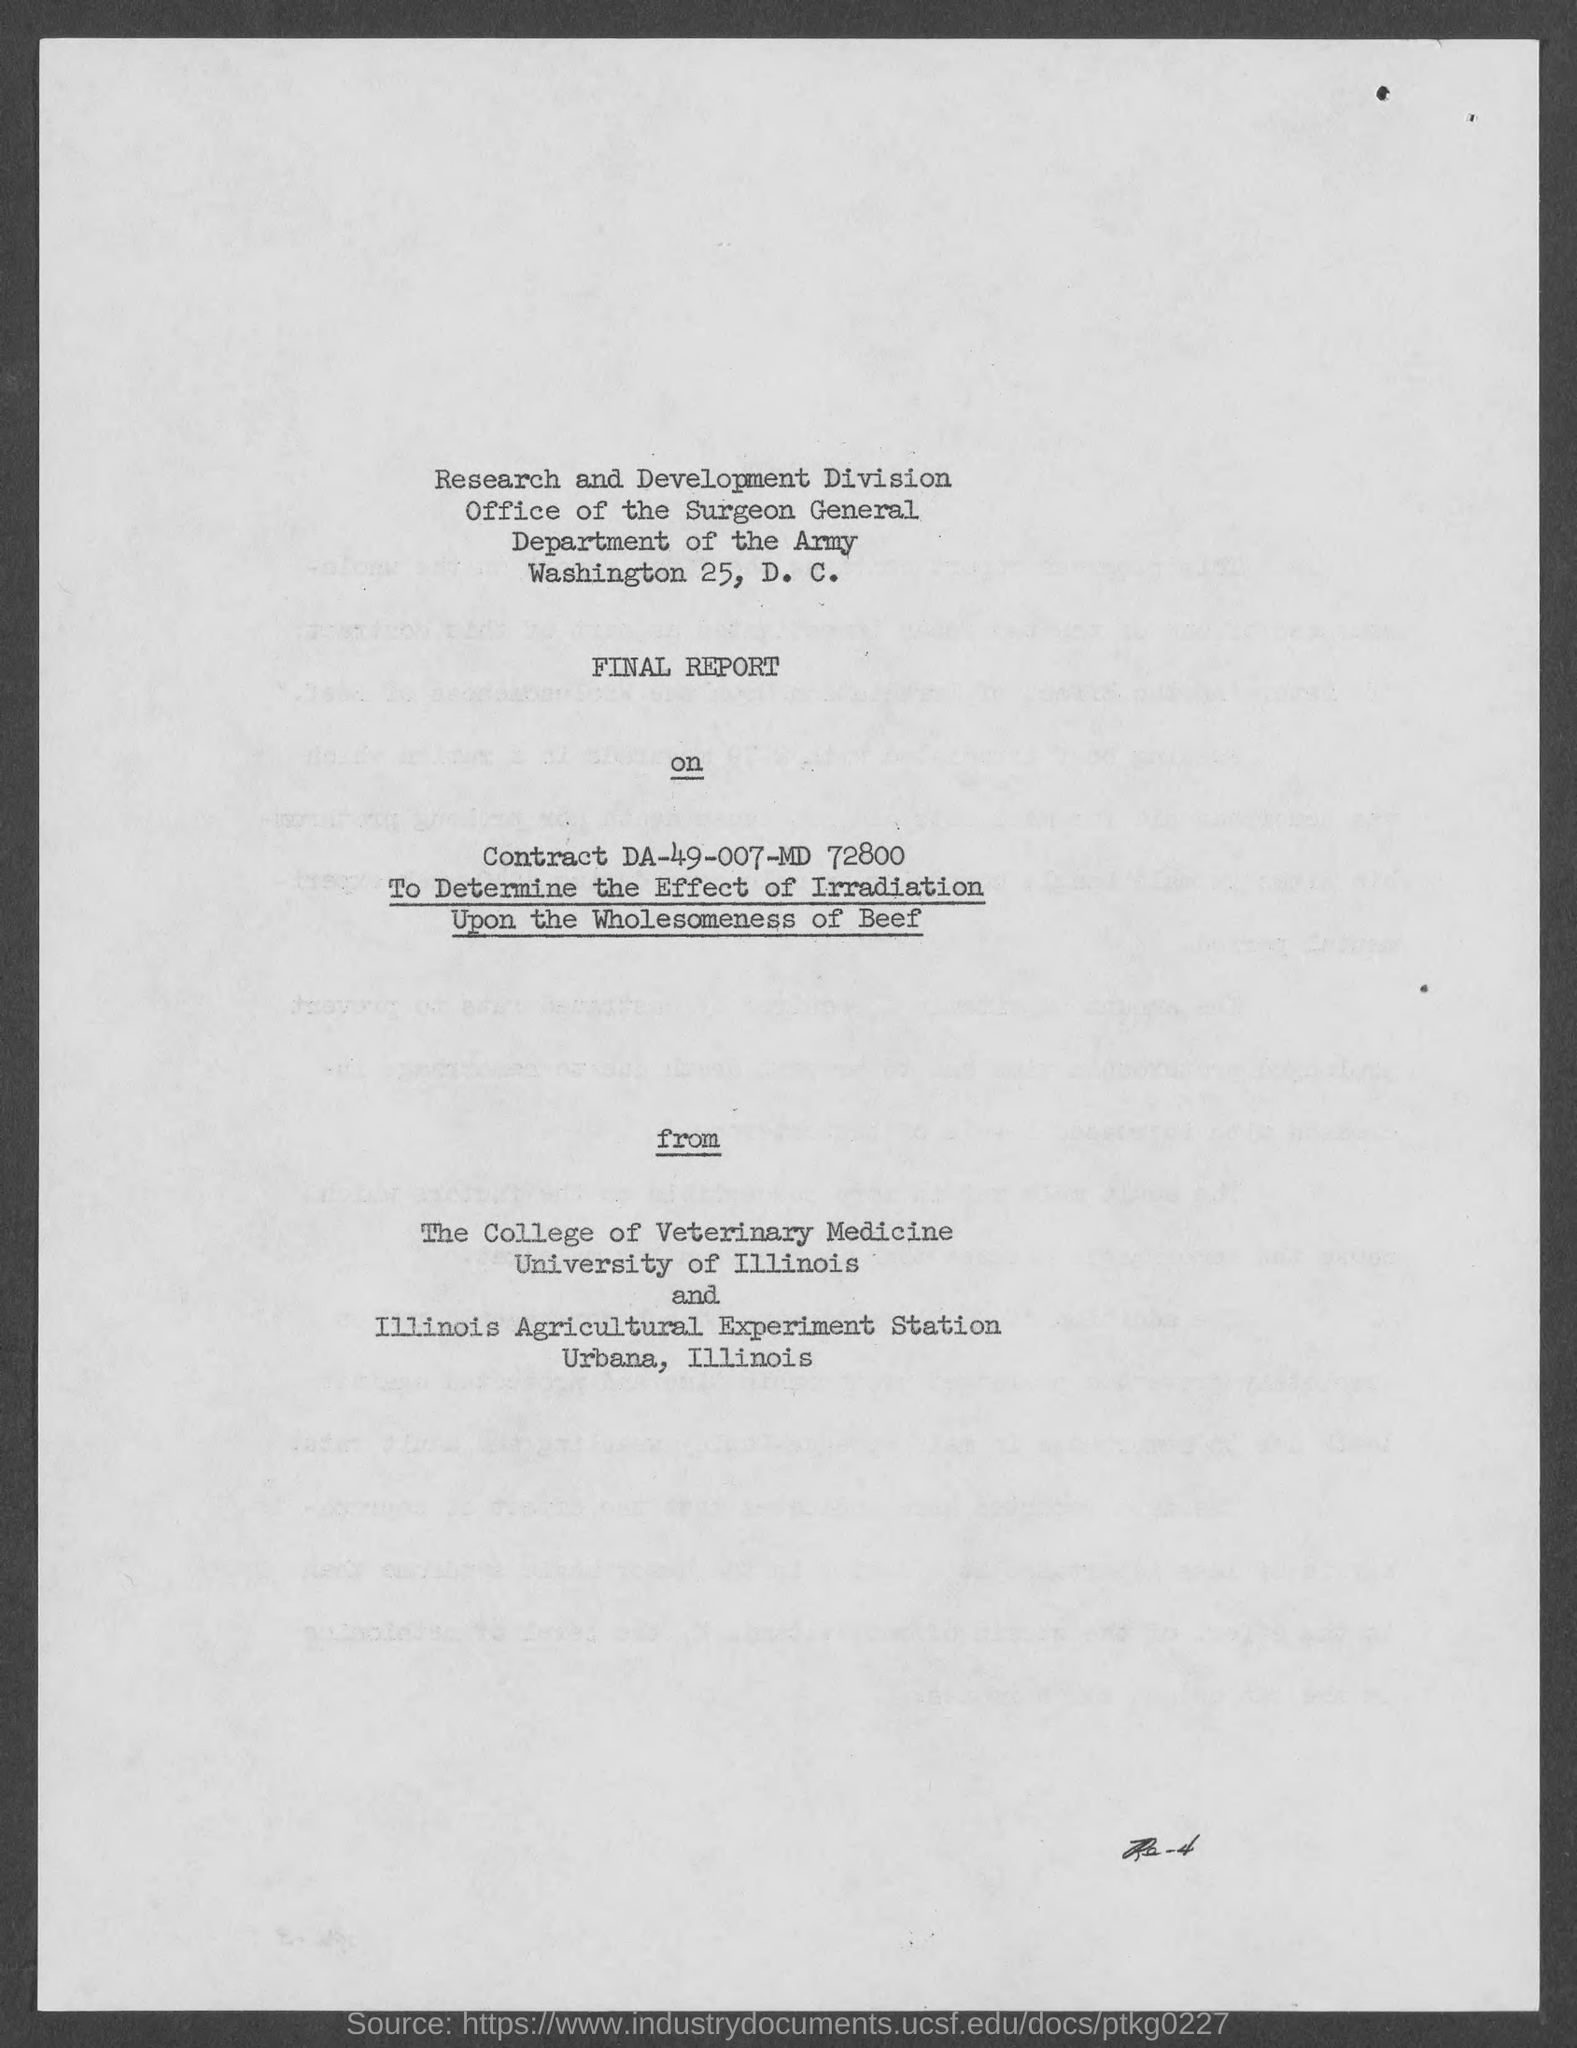Outline some significant characteristics in this image. The Department of the Army is a department within the United States federal government responsible for the management and operation of the Army, one of the military branches of the United States. The report aims to assess the impact of irradiation on the safety and quality of beef as a food item. What is Contract No. DA-49-007-MD 72800..?" is a question asking for information about a contract. 